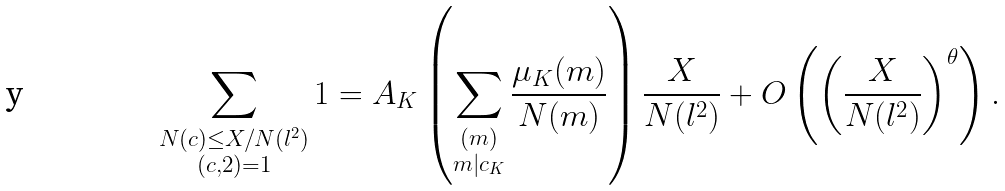<formula> <loc_0><loc_0><loc_500><loc_500>\sum _ { \substack { N ( c ) \leq X / N ( l ^ { 2 } ) \\ ( c , 2 ) = 1 } } 1 = A _ { K } \left ( \sum _ { \substack { ( m ) \\ m | c _ { K } } } \frac { \mu _ { K } ( m ) } { N ( m ) } \right ) \frac { X } { N ( l ^ { 2 } ) } + O \left ( \left ( \frac { X } { N ( l ^ { 2 } ) } \right ) ^ { \theta } \right ) .</formula> 